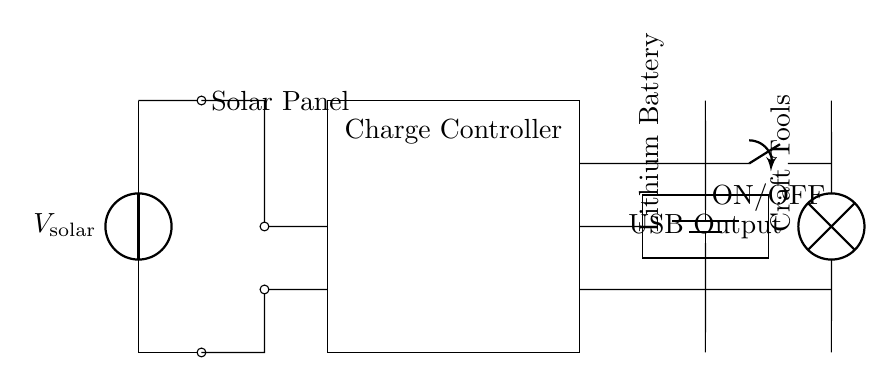What is the primary source of energy for this system? The primary source of energy is the solar panel, which is indicated in the diagram at the leftmost side. It generates voltage to charge the battery.
Answer: Solar panel What component protects the battery from overcharging? The charge controller is designed to protect the battery from overcharging, as shown in the circuit. It connects the solar panel and the battery.
Answer: Charge controller How many outputs are there for the craft tools? There is one output for the craft tools, shown connected to the battery through a switch.
Answer: One What type of battery is used in this circuit? The diagram labels the battery as a lithium battery, which indicates the type used to store energy.
Answer: Lithium What is the purpose of the USB output? The USB output provides a method to power or charge devices, as represented in the circuit. It connects to the charge controller and acts as an output.
Answer: Power devices What is the role of the switch in the circuit? The switch allows the user to turn the craft tools on or off, controlling the power flow from the battery to the load. This is crucial for managing energy use.
Answer: ON/OFF Which component converts solar energy into electrical energy? The component that converts solar energy into electrical energy is the solar panel, indicated at the beginning of the circuit.
Answer: Solar panel 